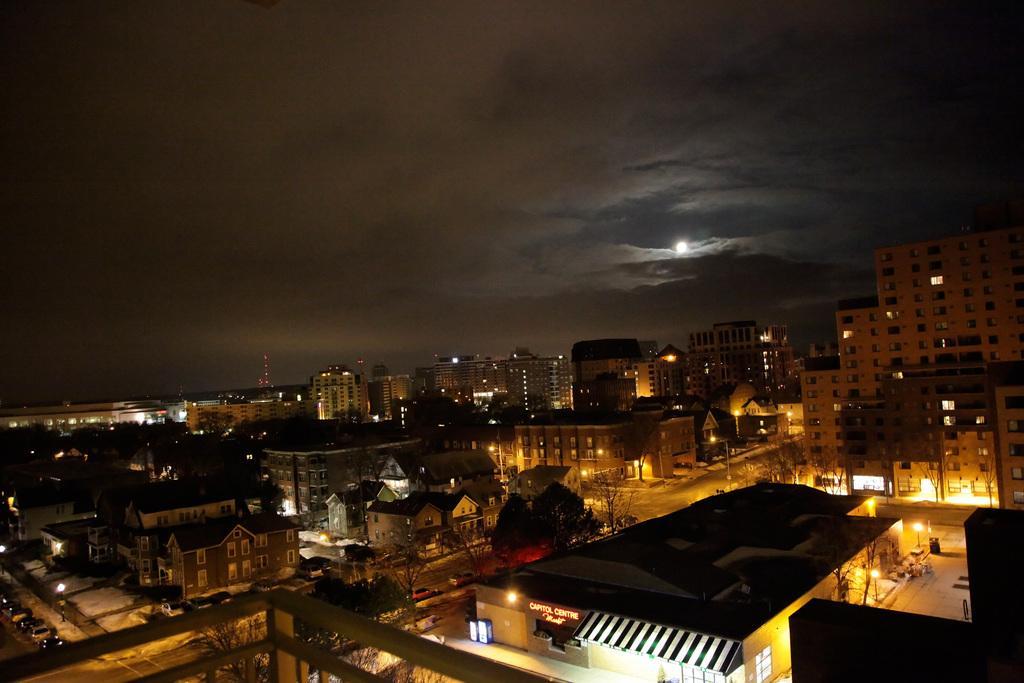How would you summarize this image in a sentence or two? In this image I can see few buildings, windows, lights, trees and few vehicles on road. I can see the sky and the moon. 